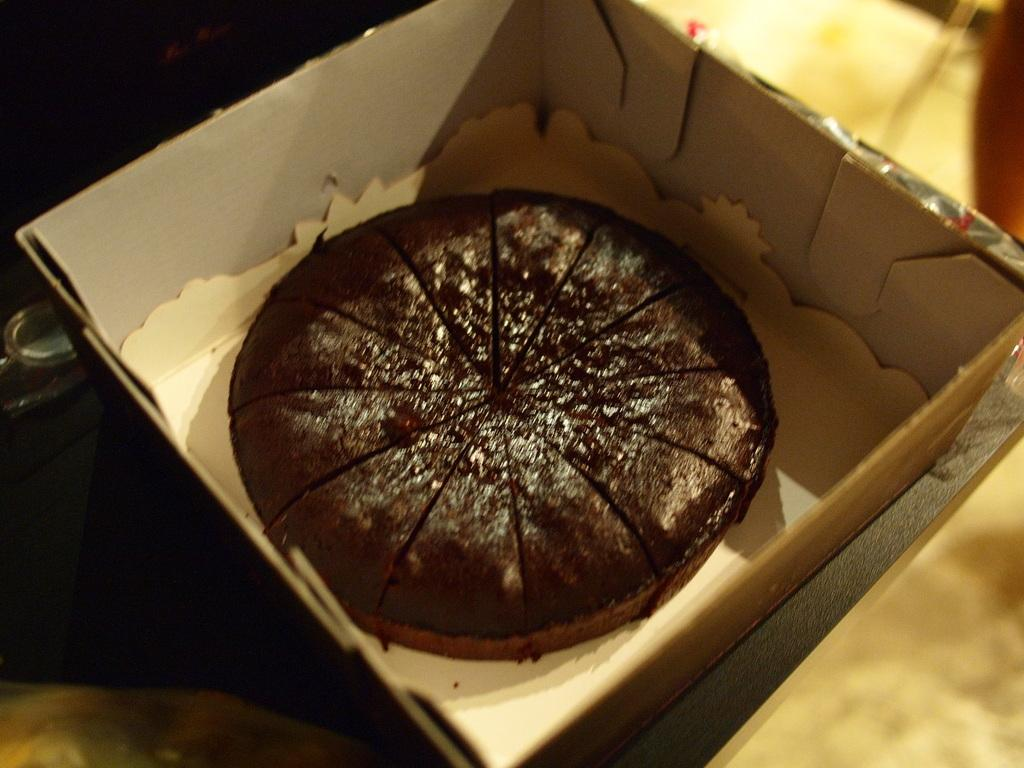What is inside the box that is visible in the image? The box contains a cake. What can be said about the color of the cake? The cake is dark brown in color. How does the image appear in terms of lighting? The image appears to be dark. What is the color of the surface on which the box is placed? The box is on a cream-colored surface. Can you tell me the weight of the cake on the scale in the image? There is no scale present in the image, and therefore no weight can be determined. 